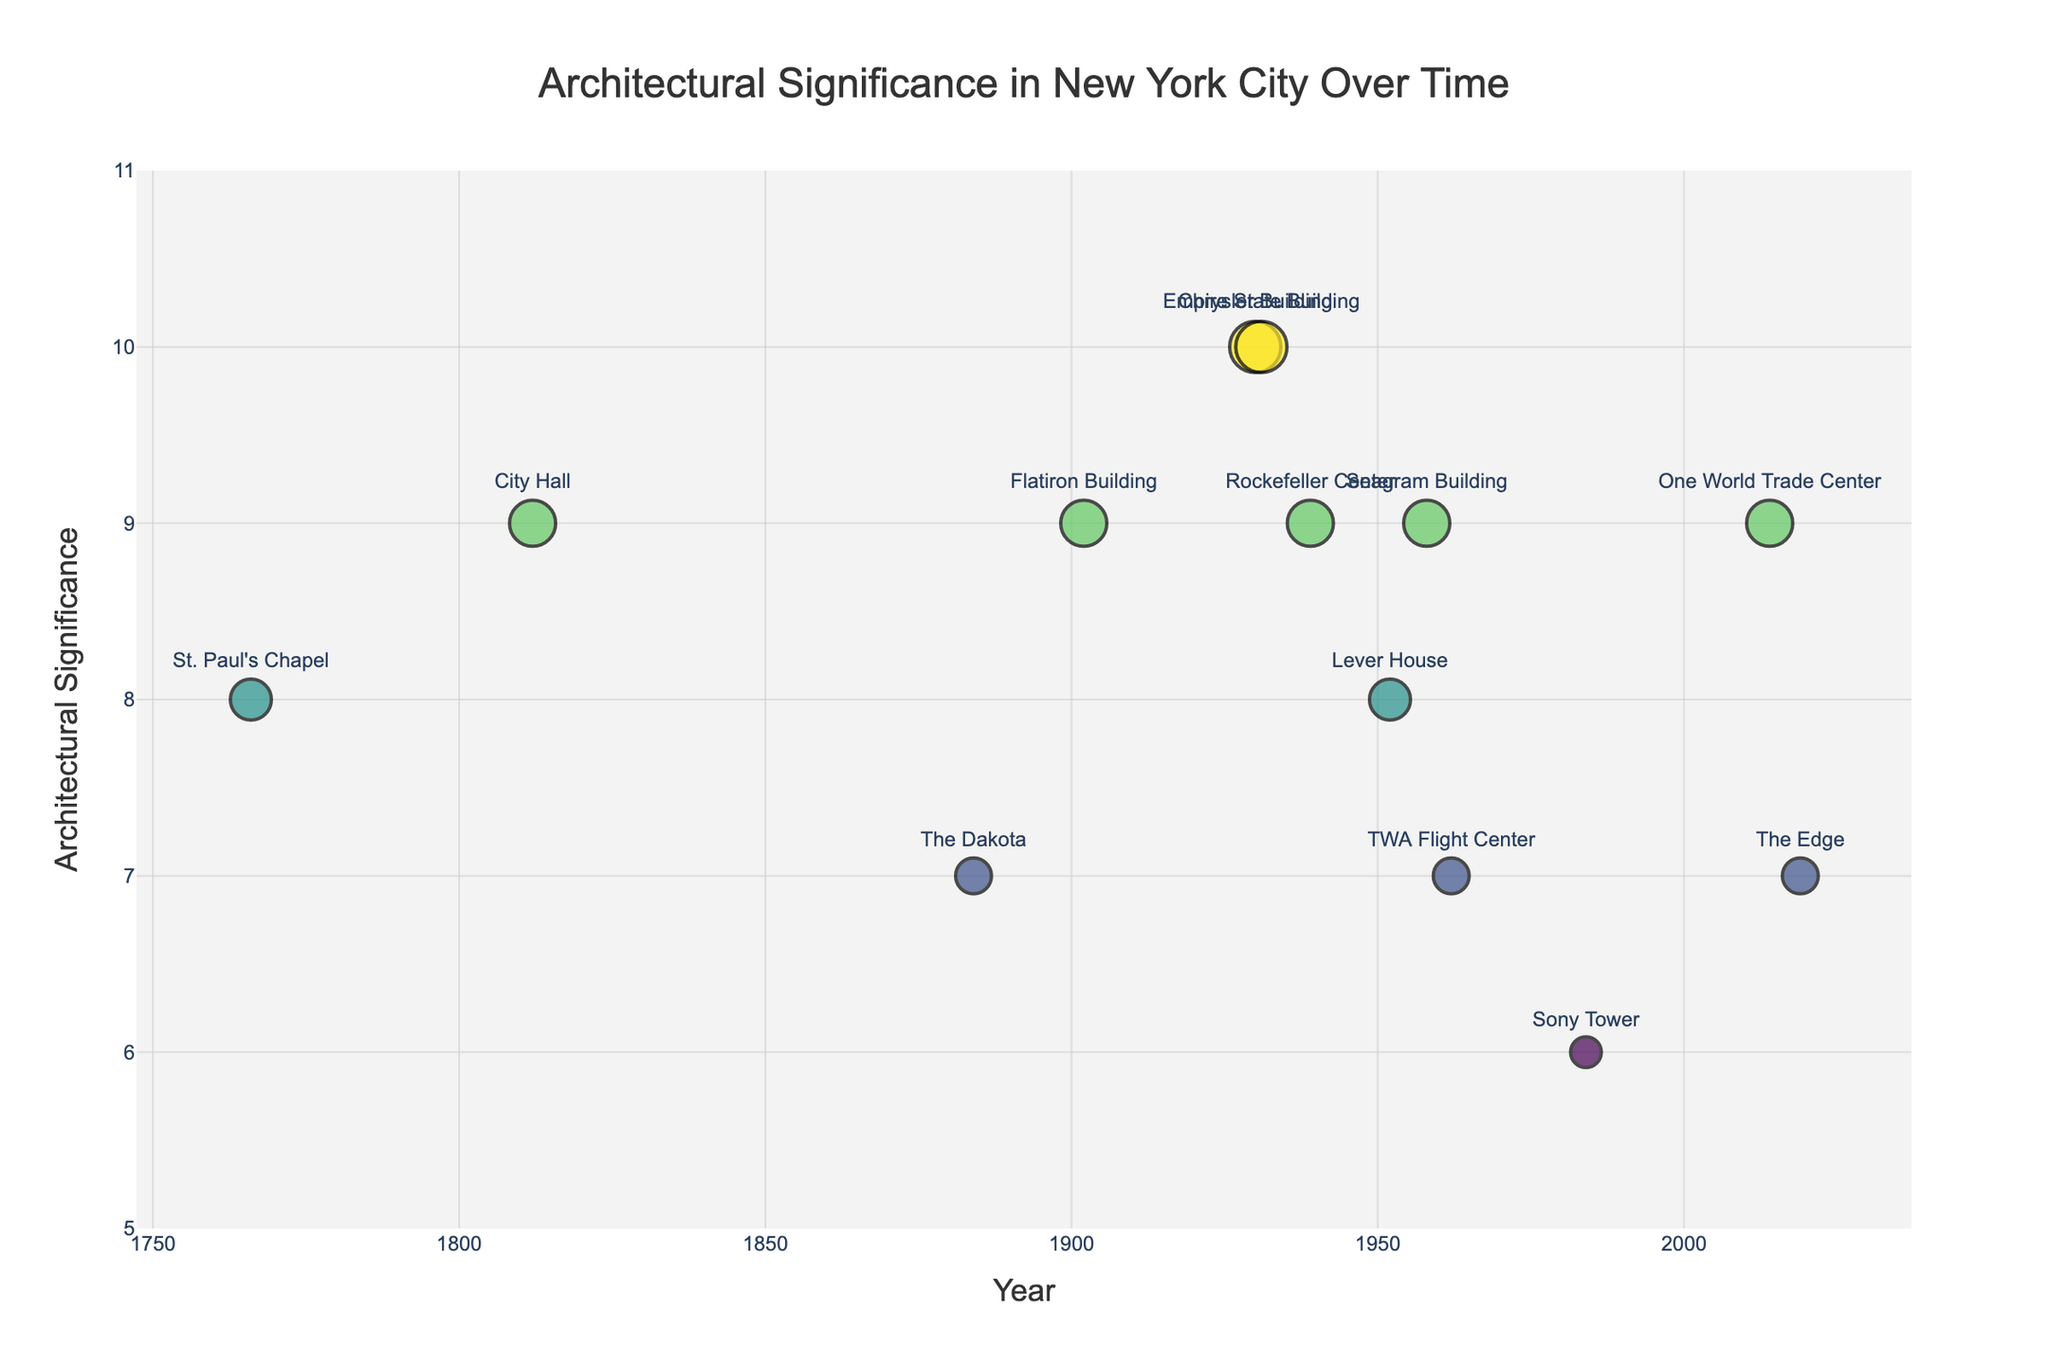What's the title of the figure? The title of the figure is prominently displayed at the top and reads "Architectural Significance in New York City Over Time".
Answer: Architectural Significance in New York City Over Time What is the range of significance values in the plot? The y-axis range for significance values is shown to run from a minimum of 5 to a maximum of 11. This can be observed directly from the axis labels.
Answer: 5 to 11 Which building has the highest significance score? By looking at the data points and hovering texts, the Chrysler Building and the Empire State Building both have the highest significance score of 10.
Answer: Chrysler Building, Empire State Building Which era has the most buildings represented in the plot? By counting the number of buildings from each era represented in the plot, it's clear that the Art Deco (Jazz Age and Roaring Twenties) and International Style (Post-War and Mid-Century) have multiple buildings, but Art Deco has slightly more.
Answer: Art Deco What are the buildings represented in the Art Deco era? The hover text on the data points reveals that the Art Deco era includes the Chrysler Building, the Empire State Building, and Rockefeller Center.
Answer: Chrysler Building, Empire State Building, Rockefeller Center How does the significance of the Colonial era building compare to that of the Contemporary era building? By looking at the y-axis values corresponding to the Colonial era (St. Paul's Chapel, Significance 8) and Contemporary era (One World Trade Center, Significance 9), we see that the Contemporary era building has a higher significance.
Answer: Contemporary era building has higher significance What's the average significance score of the buildings in the International Style? The buildings in the International Style are Lever House (Significance 8) and Seagram Building (Significance 9). The average is calculated as (8 + 9) / 2 = 8.5.
Answer: 8.5 Which building in the plot represents the Sustainable era? The hover text shows that the building representing the Sustainable era is The Edge.
Answer: The Edge Are there more buildings with a significance score above 8 or below 8? By examining the y-values, count the number of buildings with significance scores above 8 (5 buildings) and those with scores below 8 (3 buildings). There are more buildings with a significance score above 8.
Answer: Above 8 What's the significance score of the building constructed in the earliest year represented in the plot? The earliest year represented is 1766 for St. Paul's Chapel, which has a significance score of 8.
Answer: 8 